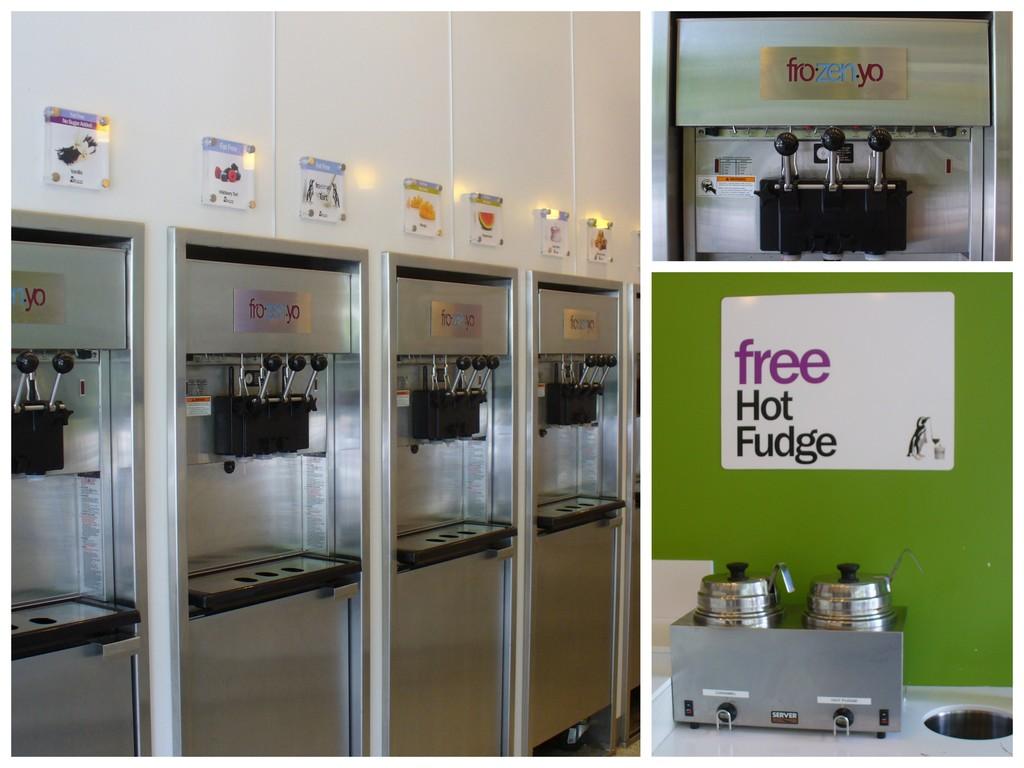What are they giving out for free here?
Your response must be concise. Hot fudge. What is the name on the yogurt dispensing machines?
Provide a short and direct response. Frozenyo. 